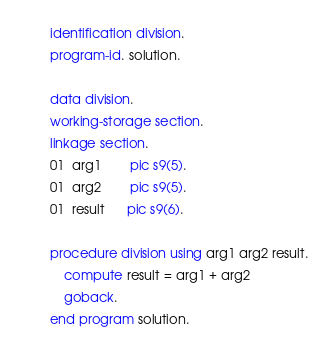<code> <loc_0><loc_0><loc_500><loc_500><_COBOL_>       identification division.
       program-id. solution.

       data division.
       working-storage section.
       linkage section.
       01  arg1        pic s9(5).
       01  arg2        pic s9(5).
       01  result      pic s9(6).

       procedure division using arg1 arg2 result.
           compute result = arg1 + arg2
           goback.
       end program solution.
</code> 